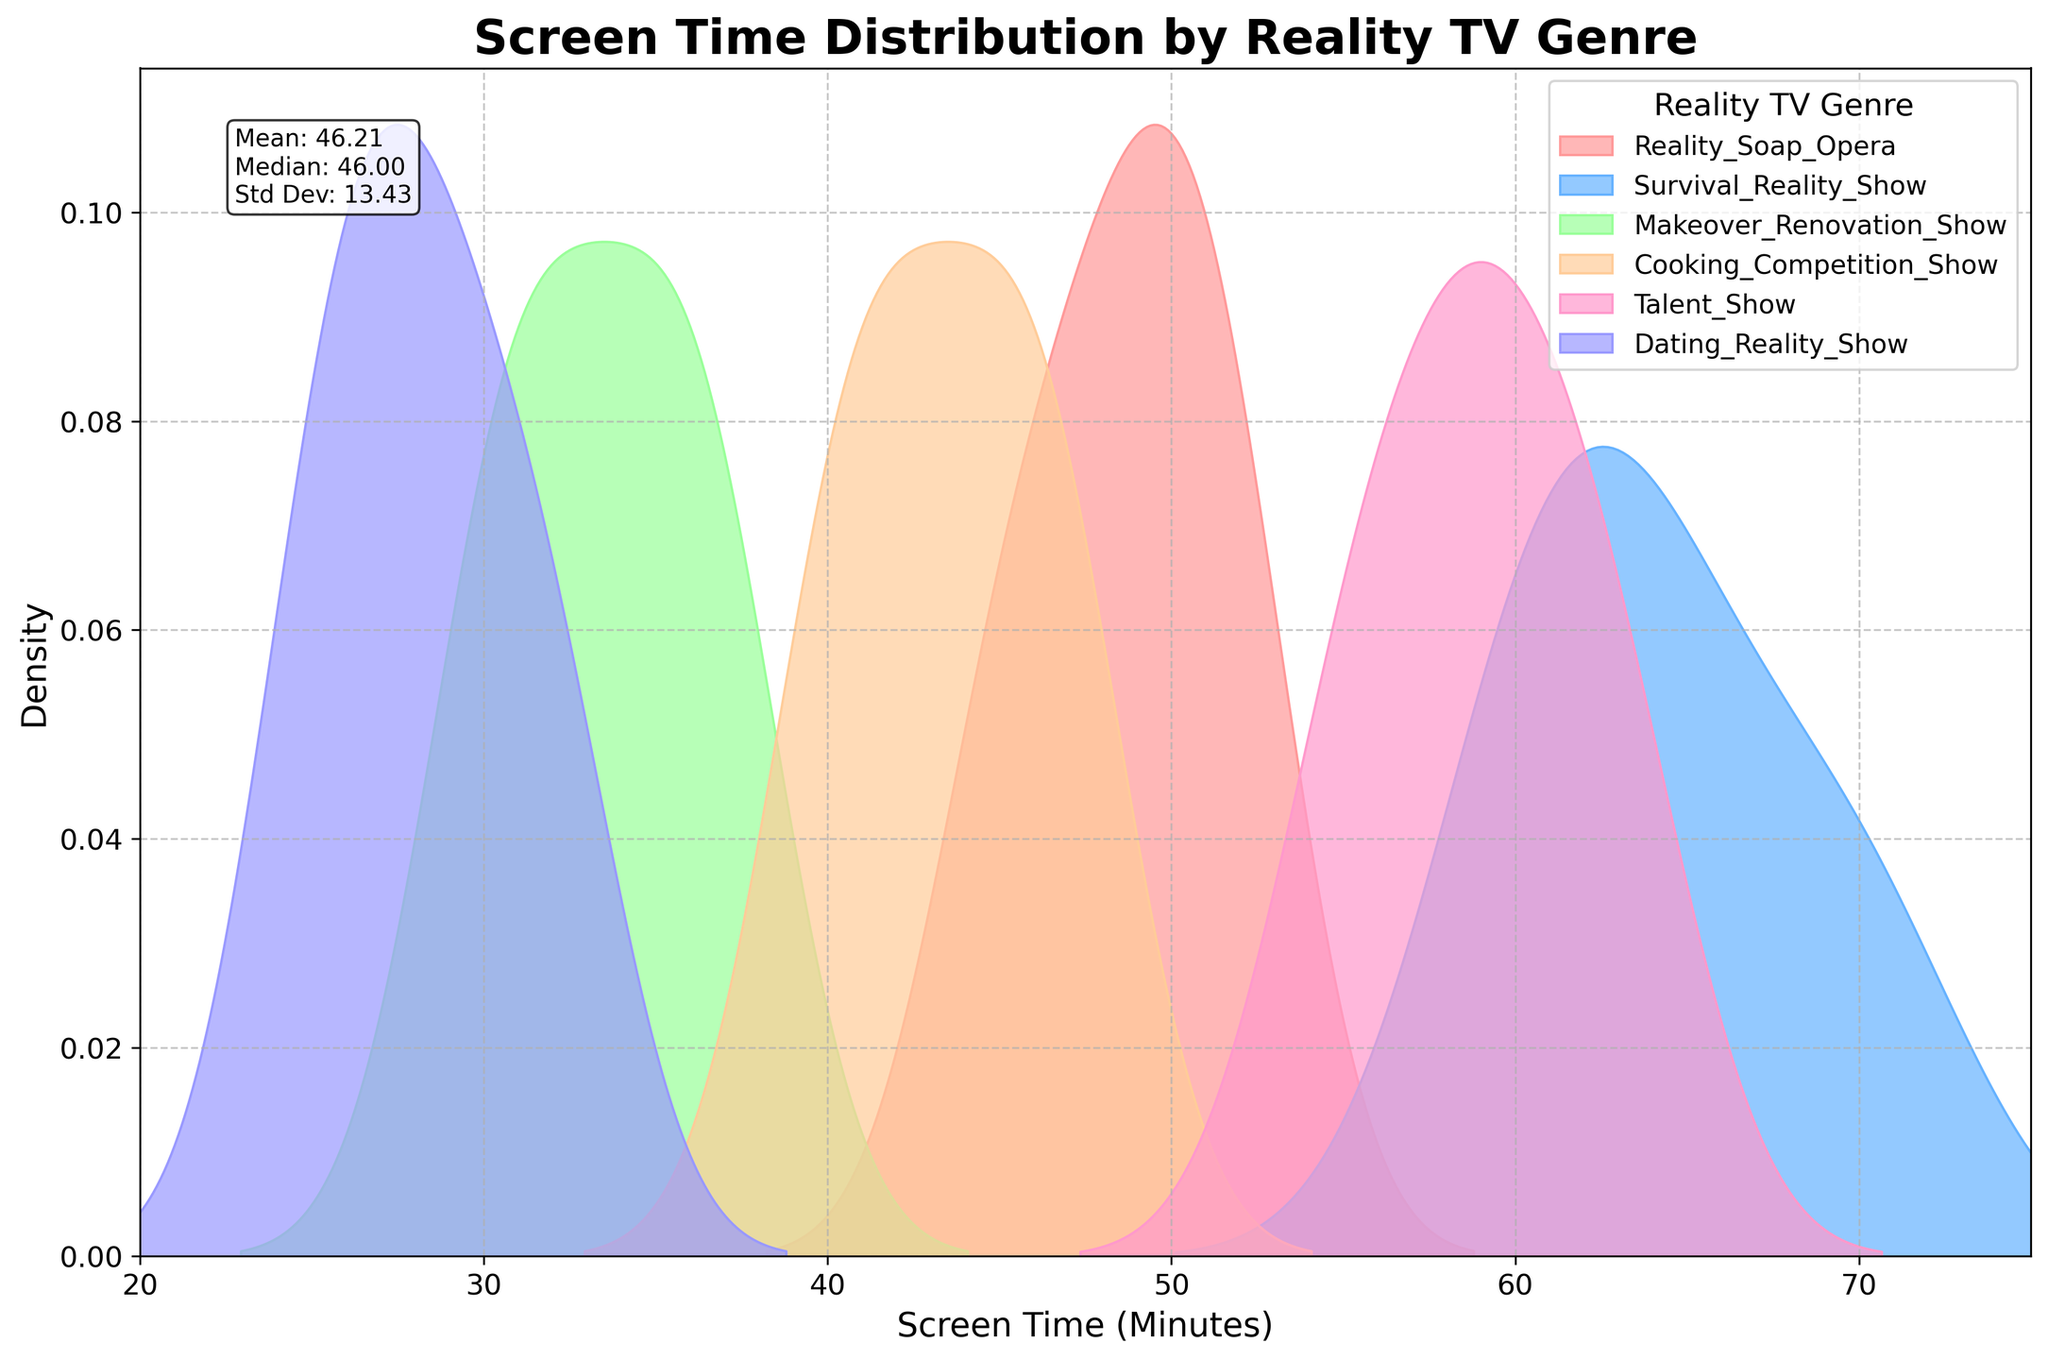What is the title of the chart? The title of the chart is typically found at the top and provides an overview of what the chart represents. It helps viewers understand the context of the data being presented.
Answer: Screen Time Distribution by Reality TV Genre What does the x-axis represent? The x-axis label is located at the bottom of the chart and indicates what the numbers along this axis represent. It helps interpret the data in terms of screen time.
Answer: Screen Time (Minutes) How many genres of reality TV are shown in the chart? By looking at the legend, which usually appears within the plot area, we can count the number of genres represented with different colors.
Answer: Six Which reality TV genre has the widest distribution of screen time? By comparing the width (spread) of the density plots for each genre, the one that spans the most time is the genre with the widest distribution.
Answer: Survival Reality Show Which genre shows the highest density (peak) of screen time at around 60 minutes? The highest density at a specific point can be identified by looking at the peak of the plot near 60 minutes for each genre.
Answer: Survival Reality Show What is the mean screen time of the reality TV genres? The mean value is usually included in a text box within the plot, summarizing key statistical measures. It's a central tendency measure of the screen time data.
Answer: 45.44 What is the trend in screen time distribution for Cooking Competition Shows? By examining the shape and skew of the density plot for Cooking Competition Shows, we can understand how the screen times are distributed around their central values.
Answer: The trend is moderately spread around the central value of 45 minutes How does the screen time distribution for Dating Reality Shows compare to Makeover Renovation Shows? By comparing the placement and spread of their density plots, we can see differences in how screen times are distributed for these two genres.
Answer: Dating Reality Shows have lower and narrower screen times compared to Makeover Renovation Shows Which Reality TV genre has the least screen time and what is the approximate range? By locating the plot that has the peaks at the lowest values on the x-axis, we identify the genre and estimate the range it covers.
Answer: Dating Reality Show, approximately 25-32 minutes Which genre's density plot is the most evenly spread? An evenly spread density plot has a flatter shape, indicating less variability in screen times. Identify the plot that fits this description.
Answer: Reality Soap Opera 